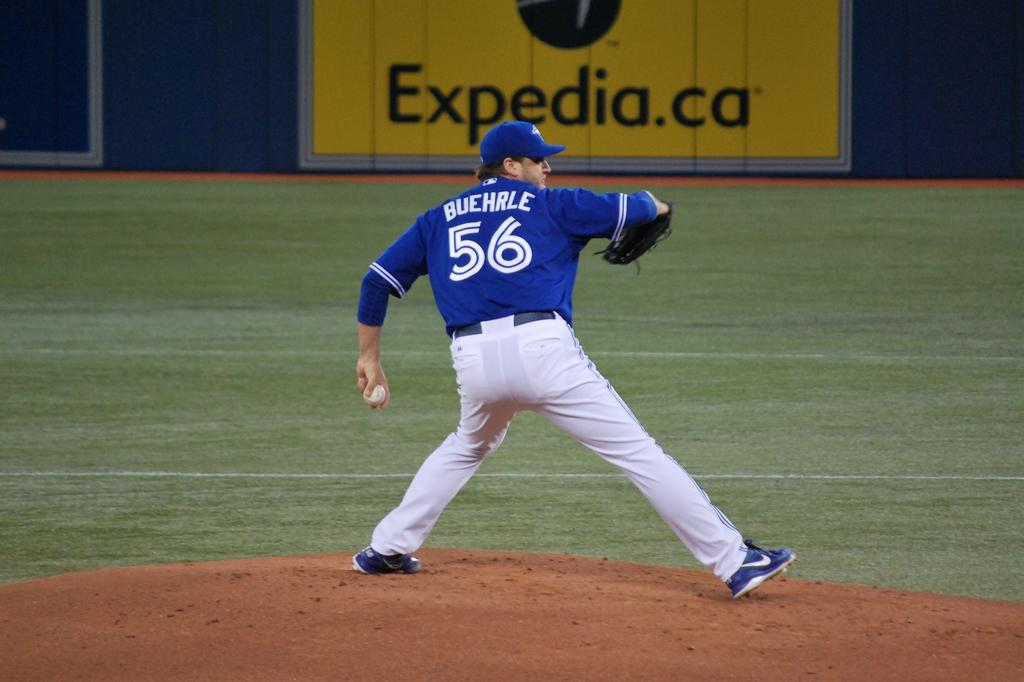Provide a one-sentence caption for the provided image. A pitcher with the blue jersey number 56 stands on a mound ready to throw. 